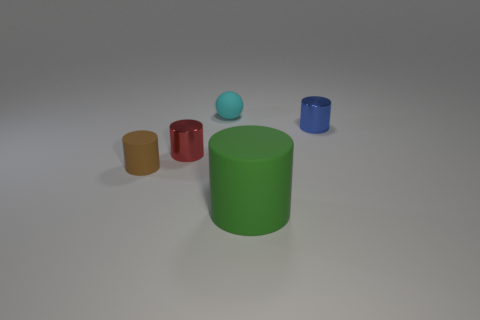Is there any other thing that is the same size as the green cylinder?
Offer a very short reply. No. What number of other objects are there of the same color as the rubber ball?
Your answer should be compact. 0. Are the big green cylinder and the tiny cyan ball to the left of the large object made of the same material?
Your answer should be very brief. Yes. There is a cylinder right of the matte object that is to the right of the tiny cyan rubber sphere; how many big cylinders are to the right of it?
Your answer should be compact. 0. Is the number of blue metallic cylinders that are left of the blue metallic cylinder less than the number of tiny cyan objects left of the tiny red object?
Provide a short and direct response. No. How many other objects are there of the same material as the blue thing?
Your response must be concise. 1. There is a brown thing that is the same size as the blue thing; what is it made of?
Offer a terse response. Rubber. How many brown things are either small shiny cylinders or small matte cylinders?
Your response must be concise. 1. There is a thing that is in front of the small blue thing and to the right of the tiny cyan rubber sphere; what is its color?
Your answer should be very brief. Green. Is the material of the tiny cylinder that is right of the large green thing the same as the green thing in front of the tiny cyan sphere?
Provide a succinct answer. No. 